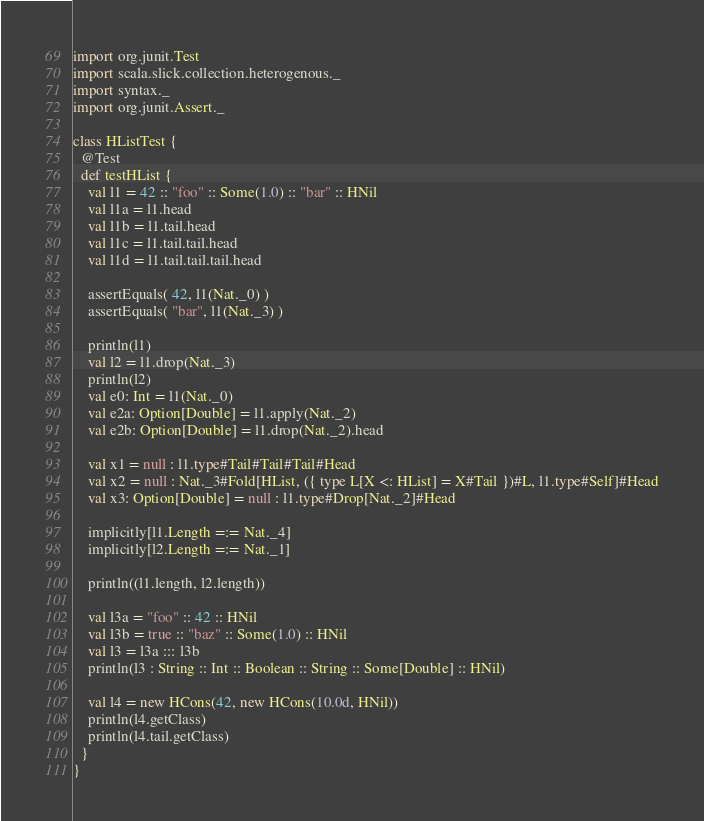<code> <loc_0><loc_0><loc_500><loc_500><_Scala_>
import org.junit.Test
import scala.slick.collection.heterogenous._
import syntax._
import org.junit.Assert._

class HListTest {
  @Test
  def testHList {
    val l1 = 42 :: "foo" :: Some(1.0) :: "bar" :: HNil
    val l1a = l1.head
    val l1b = l1.tail.head
    val l1c = l1.tail.tail.head
    val l1d = l1.tail.tail.tail.head

    assertEquals( 42, l1(Nat._0) )
    assertEquals( "bar", l1(Nat._3) )

    println(l1)
    val l2 = l1.drop(Nat._3)
    println(l2)
    val e0: Int = l1(Nat._0)
    val e2a: Option[Double] = l1.apply(Nat._2)
    val e2b: Option[Double] = l1.drop(Nat._2).head

    val x1 = null : l1.type#Tail#Tail#Tail#Head
    val x2 = null : Nat._3#Fold[HList, ({ type L[X <: HList] = X#Tail })#L, l1.type#Self]#Head
    val x3: Option[Double] = null : l1.type#Drop[Nat._2]#Head

    implicitly[l1.Length =:= Nat._4]
    implicitly[l2.Length =:= Nat._1]

    println((l1.length, l2.length))

    val l3a = "foo" :: 42 :: HNil
    val l3b = true :: "baz" :: Some(1.0) :: HNil
    val l3 = l3a ::: l3b
    println(l3 : String :: Int :: Boolean :: String :: Some[Double] :: HNil)

    val l4 = new HCons(42, new HCons(10.0d, HNil))
    println(l4.getClass)
    println(l4.tail.getClass)
  }
}
</code> 